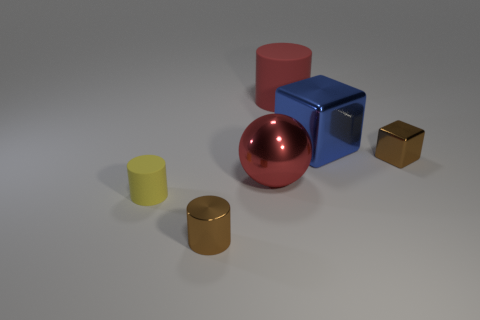There is a big thing that is the same color as the ball; what shape is it?
Give a very brief answer. Cylinder. Do the blue metal object and the rubber cylinder behind the tiny brown shiny block have the same size?
Provide a succinct answer. Yes. Is the number of big rubber cylinders left of the red ball greater than the number of purple cylinders?
Provide a succinct answer. No. What is the size of the brown cylinder that is the same material as the tiny brown cube?
Keep it short and to the point. Small. Are there any other small metallic cylinders that have the same color as the metallic cylinder?
Offer a terse response. No. How many things are yellow rubber things or metallic things that are behind the large ball?
Provide a succinct answer. 3. Are there more small yellow matte things than rubber objects?
Make the answer very short. No. The rubber object that is the same color as the metal sphere is what size?
Offer a terse response. Large. Are there any tiny blue spheres made of the same material as the big ball?
Your answer should be very brief. No. The shiny thing that is both left of the red rubber thing and to the right of the brown cylinder has what shape?
Your answer should be compact. Sphere. 